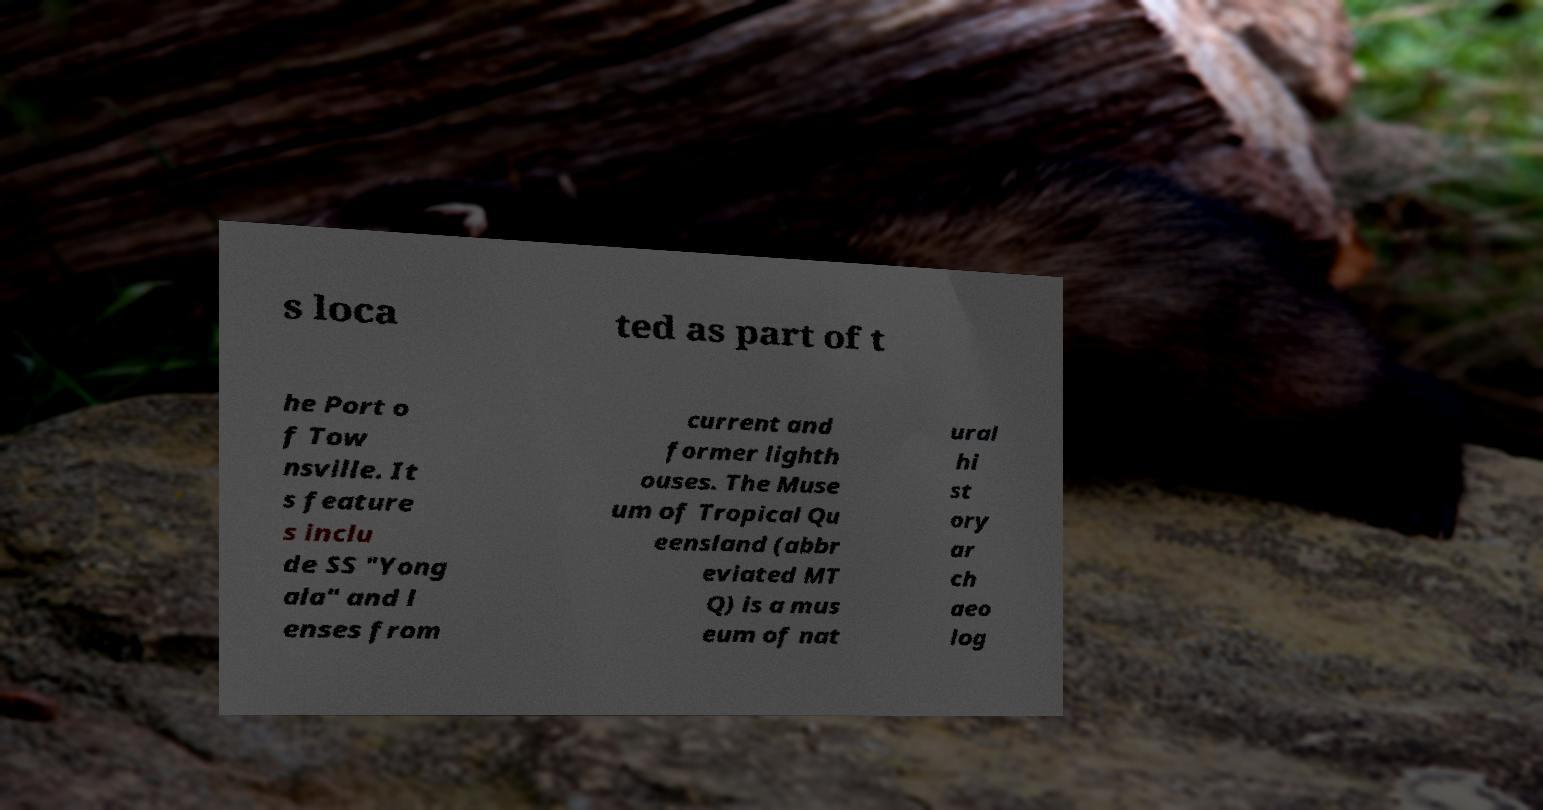For documentation purposes, I need the text within this image transcribed. Could you provide that? s loca ted as part of t he Port o f Tow nsville. It s feature s inclu de SS "Yong ala" and l enses from current and former lighth ouses. The Muse um of Tropical Qu eensland (abbr eviated MT Q) is a mus eum of nat ural hi st ory ar ch aeo log 